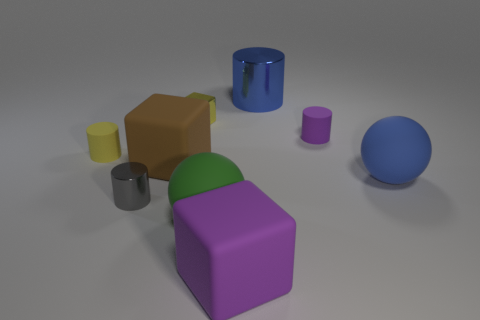What number of objects are either small rubber cylinders to the right of the big blue shiny thing or small brown cubes?
Provide a succinct answer. 1. There is a large sphere that is right of the purple cylinder; is it the same color as the large metal thing?
Give a very brief answer. Yes. What size is the blue thing that is the same shape as the small gray shiny thing?
Give a very brief answer. Large. There is a rubber thing that is behind the rubber cylinder that is in front of the tiny cylinder right of the large blue shiny object; what is its color?
Provide a succinct answer. Purple. Does the small yellow cylinder have the same material as the tiny block?
Make the answer very short. No. Are there any blue things in front of the shiny cylinder that is left of the tiny shiny thing that is behind the tiny gray thing?
Your answer should be very brief. No. Are there fewer big purple matte objects than small metal things?
Your answer should be compact. Yes. Does the purple thing on the left side of the large metal object have the same material as the yellow thing to the right of the gray metallic object?
Your answer should be compact. No. Is the number of large blue cylinders in front of the tiny shiny cube less than the number of cyan metal balls?
Your answer should be very brief. No. What number of matte spheres are to the right of the rubber block right of the big brown object?
Provide a succinct answer. 1. 